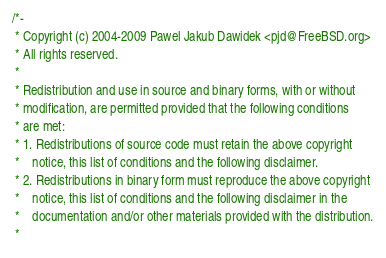Convert code to text. <code><loc_0><loc_0><loc_500><loc_500><_C_>/*-
 * Copyright (c) 2004-2009 Pawel Jakub Dawidek <pjd@FreeBSD.org>
 * All rights reserved.
 *
 * Redistribution and use in source and binary forms, with or without
 * modification, are permitted provided that the following conditions
 * are met:
 * 1. Redistributions of source code must retain the above copyright
 *    notice, this list of conditions and the following disclaimer.
 * 2. Redistributions in binary form must reproduce the above copyright
 *    notice, this list of conditions and the following disclaimer in the
 *    documentation and/or other materials provided with the distribution.
 *</code> 